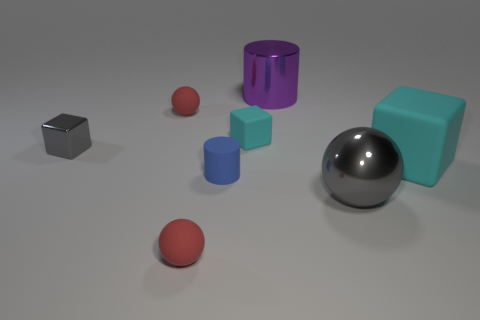How do the textures and colors of the objects compare? The objects display a mix of textures and colors. The spheres and the small silver cube have a reflective, shiny finish that catches the light, while the teal cube, blue cylinder, and purple cylinder have a soft, matte finish. In terms of color, we have a cool palette dominated by blues and teals, complemented by the warm red of the smaller spheres and the neutral gray of the shiny cube and large sphere. This variety creates an interesting contrast and visual appeal in the image. 